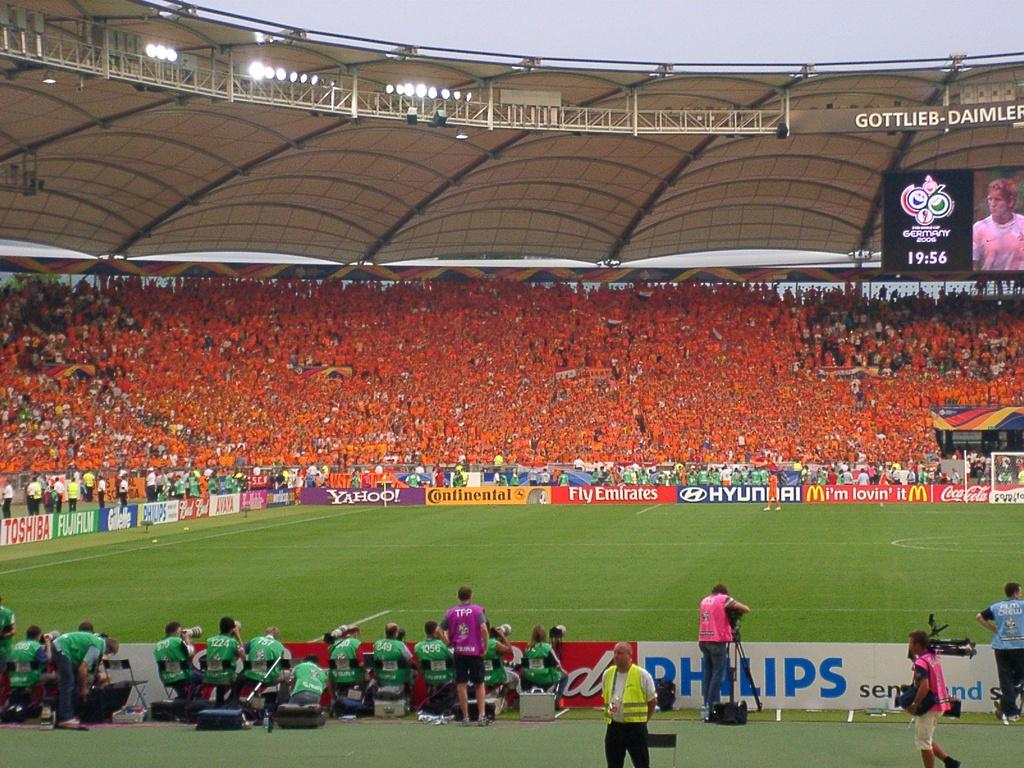Which fast food company is sponsering at the game?
Make the answer very short. Mcdonalds. What country is hosting this event?
Give a very brief answer. Germany. 